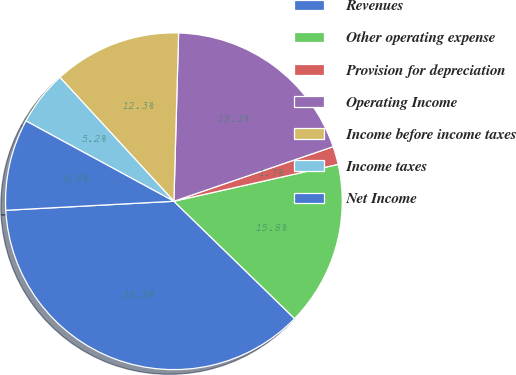Convert chart to OTSL. <chart><loc_0><loc_0><loc_500><loc_500><pie_chart><fcel>Revenues<fcel>Other operating expense<fcel>Provision for depreciation<fcel>Operating Income<fcel>Income before income taxes<fcel>Income taxes<fcel>Net Income<nl><fcel>36.87%<fcel>15.79%<fcel>1.74%<fcel>19.3%<fcel>12.28%<fcel>5.25%<fcel>8.77%<nl></chart> 